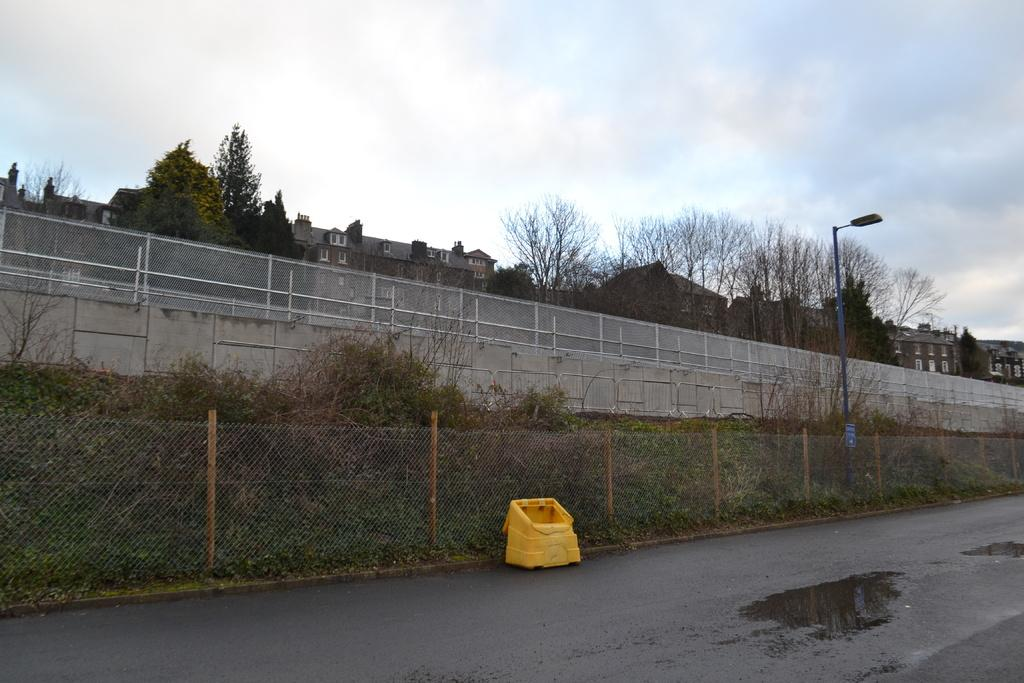What is the main structure visible in the image? There is a wall in the image. What is located in front of the wall? There are many plants in front of the wall. How are the plants protected or contained? There is fencing around the plants. What can be seen behind the wall? There are houses and trees visible behind the wall. Can you see a cat using its elbow to climb the wall in the image? There is no cat or any indication of climbing in the image. 